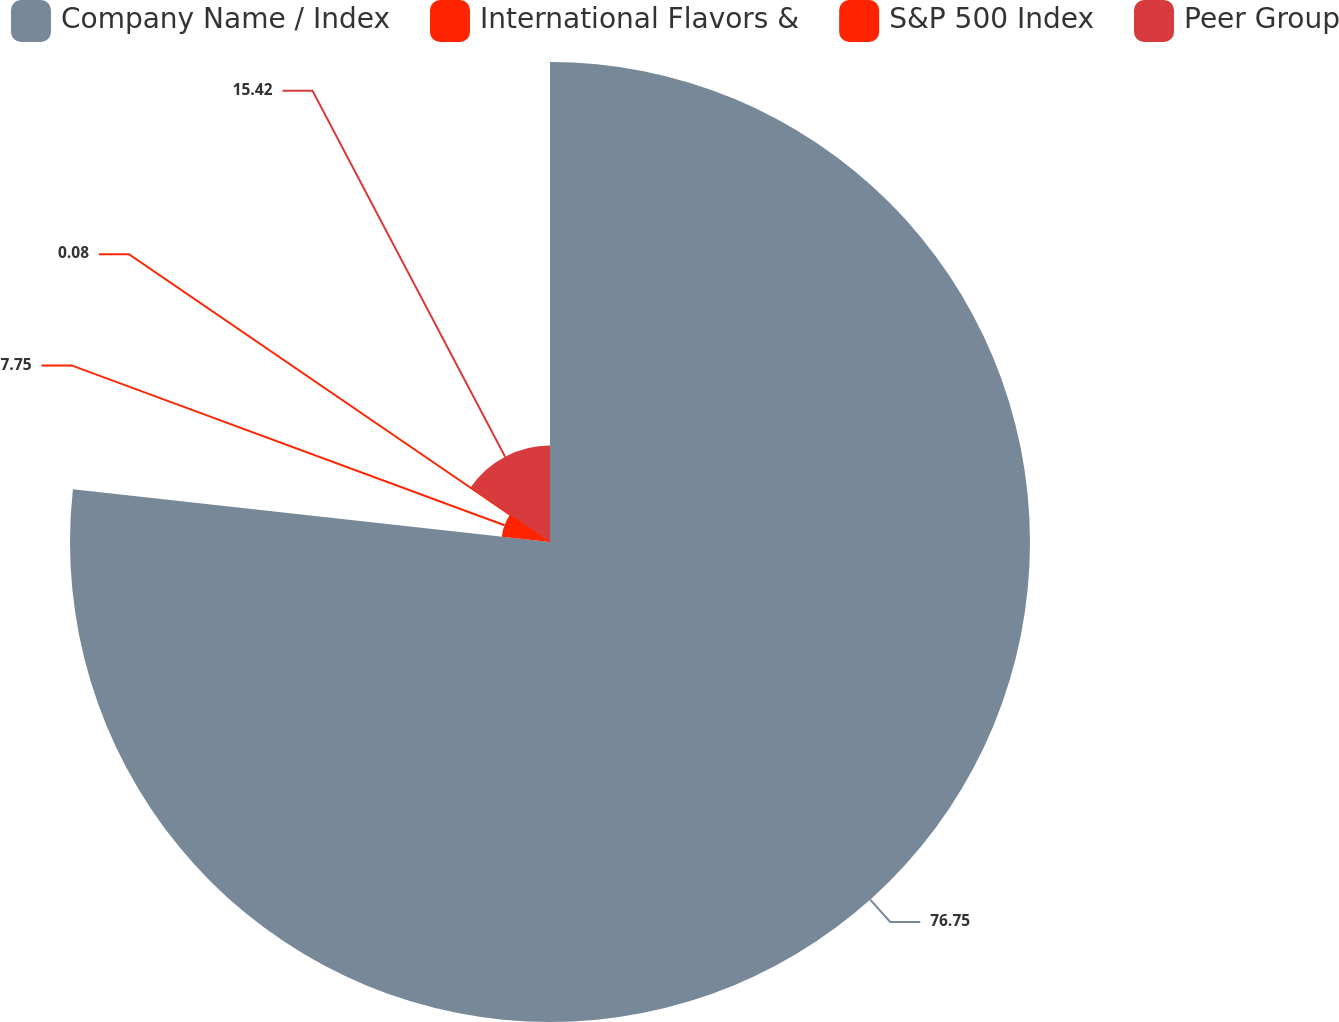Convert chart to OTSL. <chart><loc_0><loc_0><loc_500><loc_500><pie_chart><fcel>Company Name / Index<fcel>International Flavors &<fcel>S&P 500 Index<fcel>Peer Group<nl><fcel>76.76%<fcel>7.75%<fcel>0.08%<fcel>15.42%<nl></chart> 